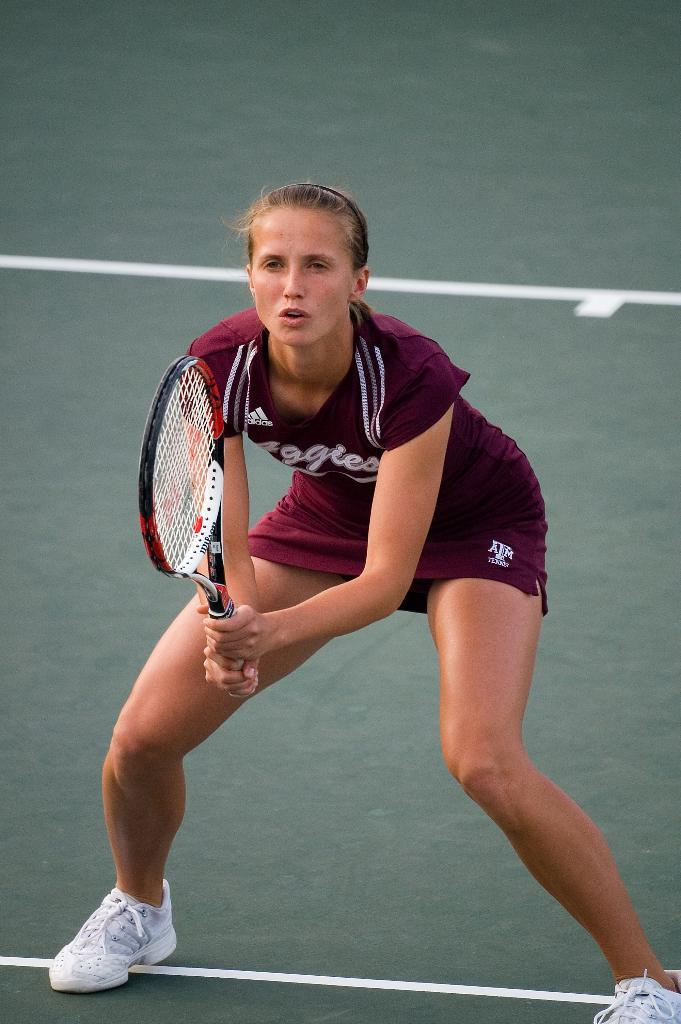Who is present in the image? There is a woman in the image. What is the woman holding in the image? The woman is holding a racket. Where is the woman standing in the image? The woman is standing in a court. What type of chicken can be seen in the image? There is no chicken present in the image. How many carts are visible in the image? There are no carts visible in the image. 